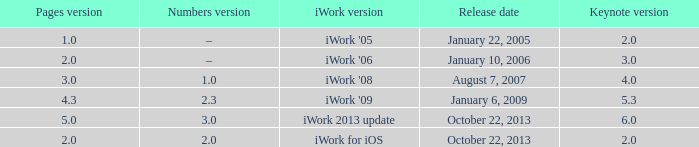What version of iWork was released on October 22, 2013 with a pages version greater than 2? Iwork 2013 update. 